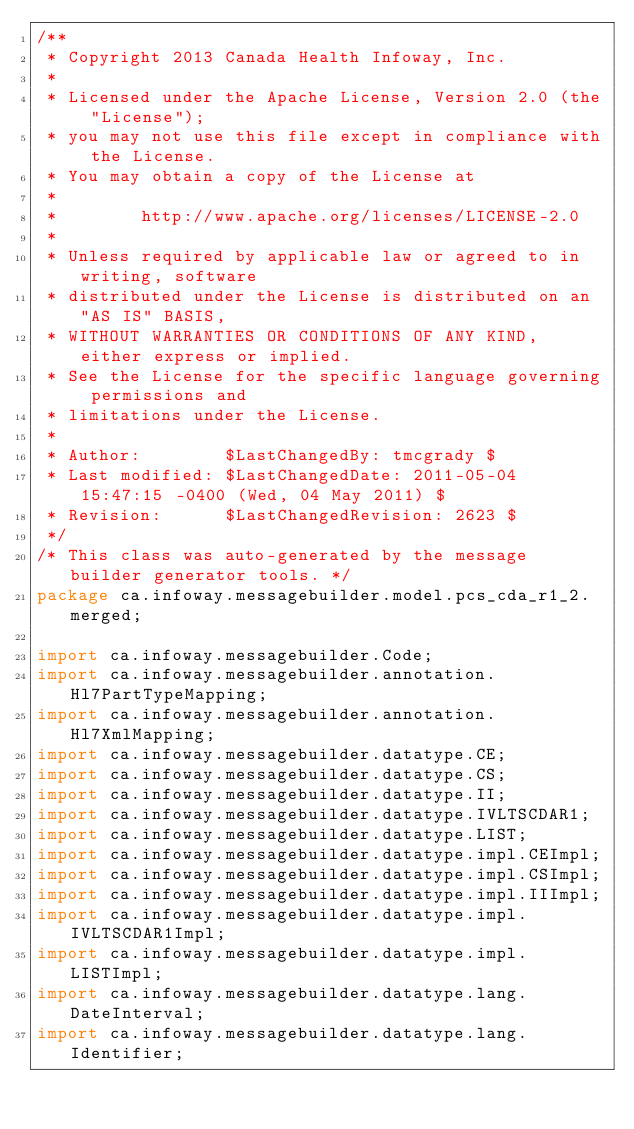<code> <loc_0><loc_0><loc_500><loc_500><_Java_>/**
 * Copyright 2013 Canada Health Infoway, Inc.
 *
 * Licensed under the Apache License, Version 2.0 (the "License");
 * you may not use this file except in compliance with the License.
 * You may obtain a copy of the License at
 *
 *        http://www.apache.org/licenses/LICENSE-2.0
 *
 * Unless required by applicable law or agreed to in writing, software
 * distributed under the License is distributed on an "AS IS" BASIS,
 * WITHOUT WARRANTIES OR CONDITIONS OF ANY KIND, either express or implied.
 * See the License for the specific language governing permissions and
 * limitations under the License.
 *
 * Author:        $LastChangedBy: tmcgrady $
 * Last modified: $LastChangedDate: 2011-05-04 15:47:15 -0400 (Wed, 04 May 2011) $
 * Revision:      $LastChangedRevision: 2623 $
 */
/* This class was auto-generated by the message builder generator tools. */
package ca.infoway.messagebuilder.model.pcs_cda_r1_2.merged;

import ca.infoway.messagebuilder.Code;
import ca.infoway.messagebuilder.annotation.Hl7PartTypeMapping;
import ca.infoway.messagebuilder.annotation.Hl7XmlMapping;
import ca.infoway.messagebuilder.datatype.CE;
import ca.infoway.messagebuilder.datatype.CS;
import ca.infoway.messagebuilder.datatype.II;
import ca.infoway.messagebuilder.datatype.IVLTSCDAR1;
import ca.infoway.messagebuilder.datatype.LIST;
import ca.infoway.messagebuilder.datatype.impl.CEImpl;
import ca.infoway.messagebuilder.datatype.impl.CSImpl;
import ca.infoway.messagebuilder.datatype.impl.IIImpl;
import ca.infoway.messagebuilder.datatype.impl.IVLTSCDAR1Impl;
import ca.infoway.messagebuilder.datatype.impl.LISTImpl;
import ca.infoway.messagebuilder.datatype.lang.DateInterval;
import ca.infoway.messagebuilder.datatype.lang.Identifier;</code> 